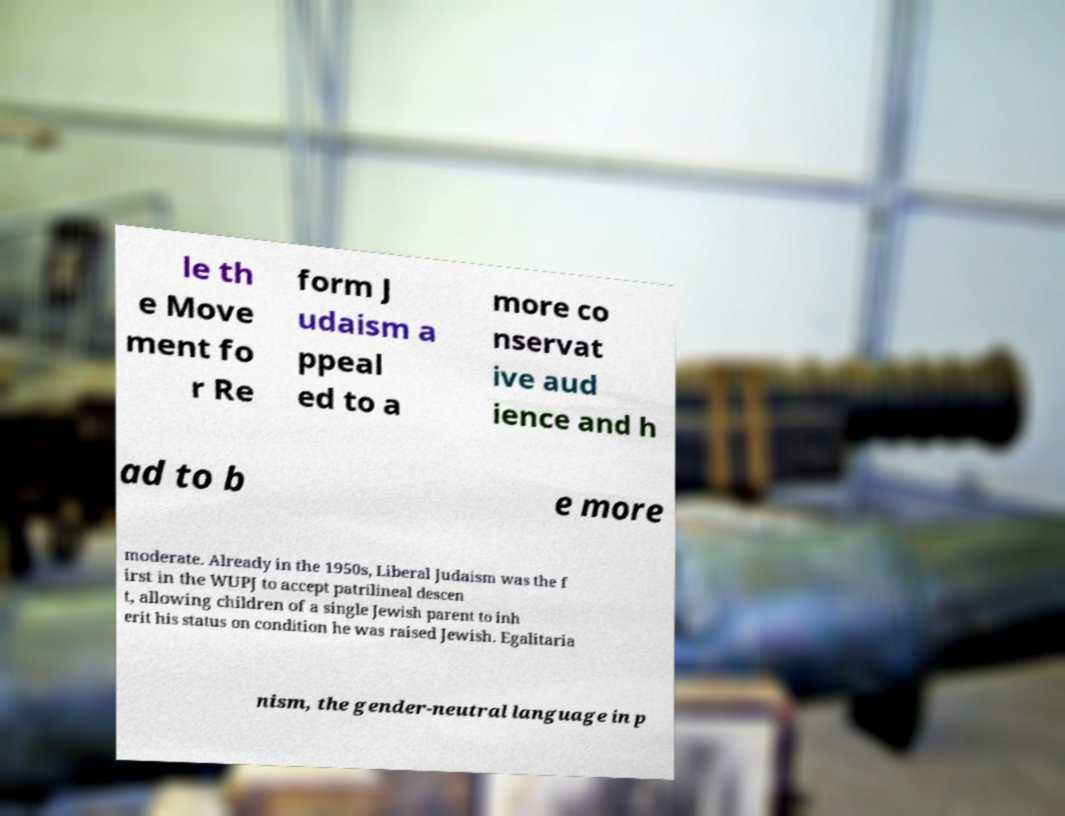Can you accurately transcribe the text from the provided image for me? le th e Move ment fo r Re form J udaism a ppeal ed to a more co nservat ive aud ience and h ad to b e more moderate. Already in the 1950s, Liberal Judaism was the f irst in the WUPJ to accept patrilineal descen t, allowing children of a single Jewish parent to inh erit his status on condition he was raised Jewish. Egalitaria nism, the gender-neutral language in p 